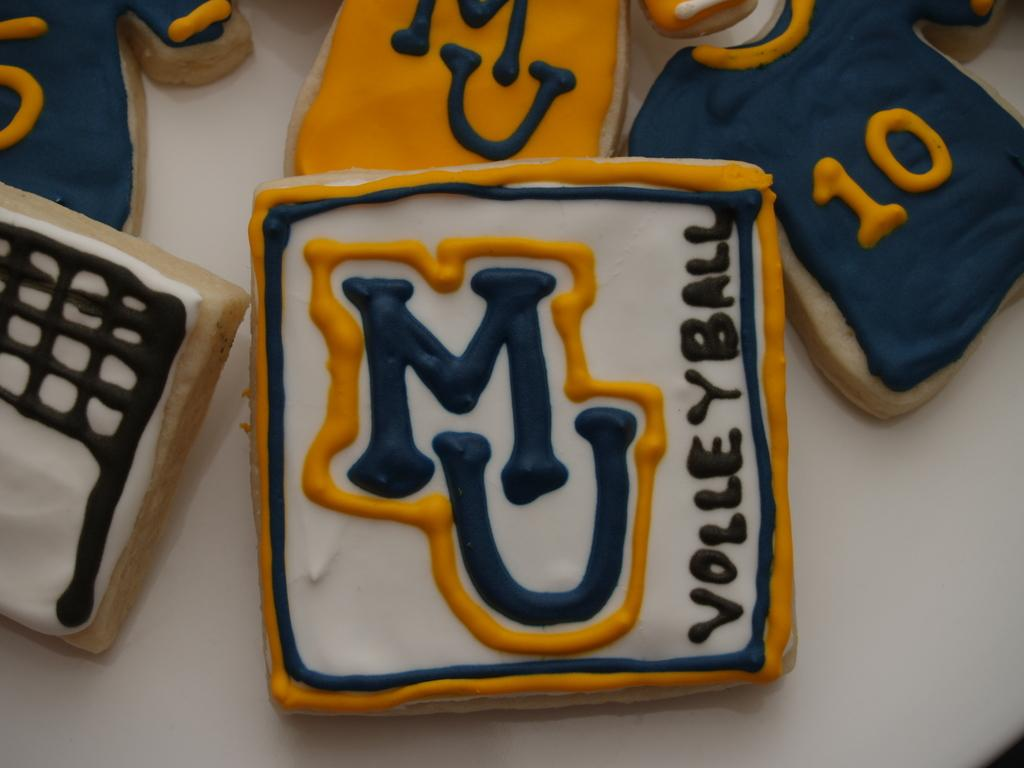<image>
Create a compact narrative representing the image presented. Cookies decorated with blue and yellow icing for MU Volleyball 